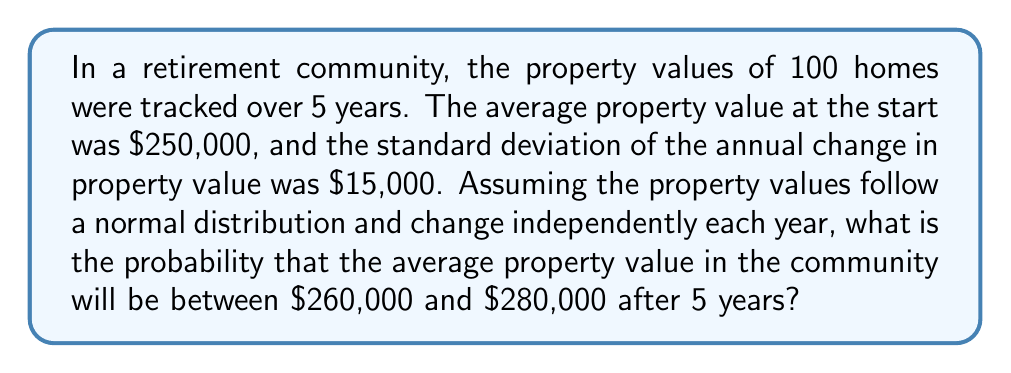Could you help me with this problem? Let's approach this step-by-step:

1) First, we need to calculate the standard error of the mean for the property values after 5 years.

   The variance of the change over 5 years is: $5 \times (15000)^2 = 1.125 \times 10^9$

   The standard deviation over 5 years is: $\sqrt{1.125 \times 10^9} = 33,541.02$

   The standard error of the mean for 100 properties is:
   $$ SE = \frac{33541.02}{\sqrt{100}} = 3354.10 $$

2) The mean of the distribution after 5 years will be $250,000 (initial value)

3) We can standardize the given range using the z-score formula:
   $$ z = \frac{x - \mu}{\sigma} $$

   For $260,000: z_1 = \frac{260000 - 250000}{3354.10} = 2.98$
   For $280,000: z_2 = \frac{280000 - 250000}{3354.10} = 8.94$

4) The probability is the area under the standard normal curve between these z-scores:
   $$ P(260000 < X < 280000) = \Phi(8.94) - \Phi(2.98) $$

   Where $\Phi$ is the cumulative distribution function of the standard normal distribution.

5) Using a standard normal table or calculator:
   $\Phi(8.94) \approx 1$
   $\Phi(2.98) \approx 0.9986$

6) Therefore, the probability is:
   $$ 1 - 0.9986 = 0.0014 $$
Answer: 0.0014 or 0.14% 